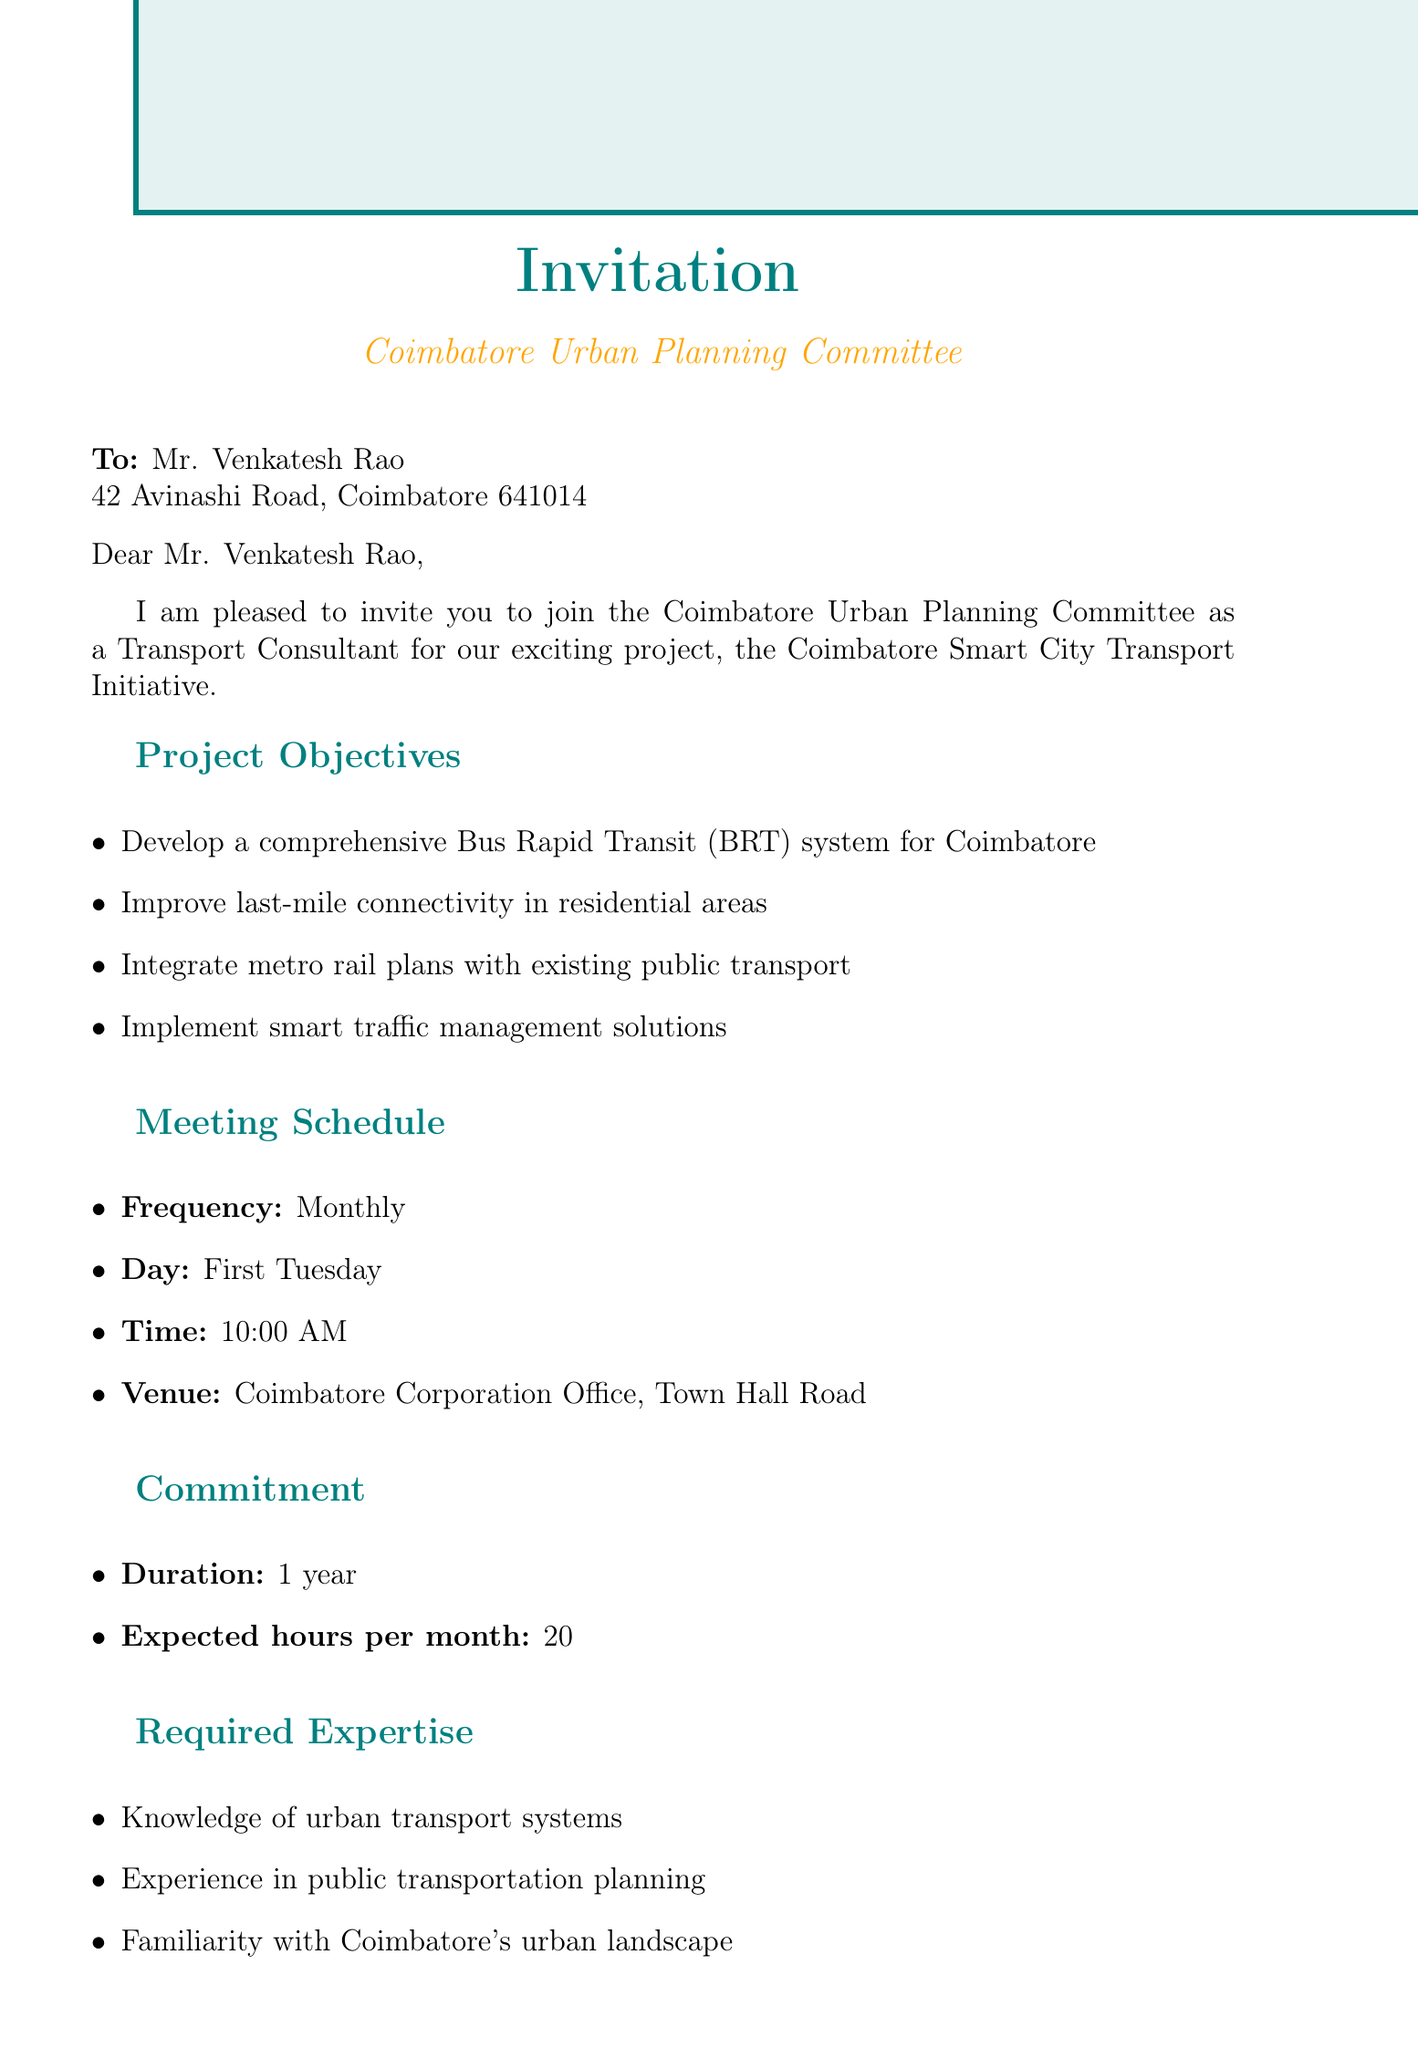What is the role offered to Mr. Venkatesh Rao? The document states that the role offered is as a Transport Consultant.
Answer: Transport Consultant What is the name of the project? The name of the project mentioned in the document is the Coimbatore Smart City Transport Initiative.
Answer: Coimbatore Smart City Transport Initiative When is the meeting scheduled to take place? The meeting is scheduled for the first Tuesday of each month.
Answer: First Tuesday How many expected hours per month is the commitment? The expected hours per month required for the role is stated in the document as 20.
Answer: 20 Who is the contact person for any queries? The contact person mentioned in the email for any queries is Mrs. Lakshmi Narayan.
Answer: Mrs. Lakshmi Narayan What is one of the project objectives? The document lists several objectives, one being to develop a comprehensive Bus Rapid Transit (BRT) system.
Answer: Develop a comprehensive Bus Rapid Transit (BRT) system What is the duration of the commitment? The document specifies the duration of the commitment as 1 year.
Answer: 1 year Where is the venue for the meetings? The venue for the meetings is stated in the document as the Coimbatore Corporation Office, Town Hall Road.
Answer: Coimbatore Corporation Office, Town Hall Road What is the title of the sender? The title of the sender as stated in the document is Secretary, Coimbatore Urban Planning Committee.
Answer: Secretary, Coimbatore Urban Planning Committee 